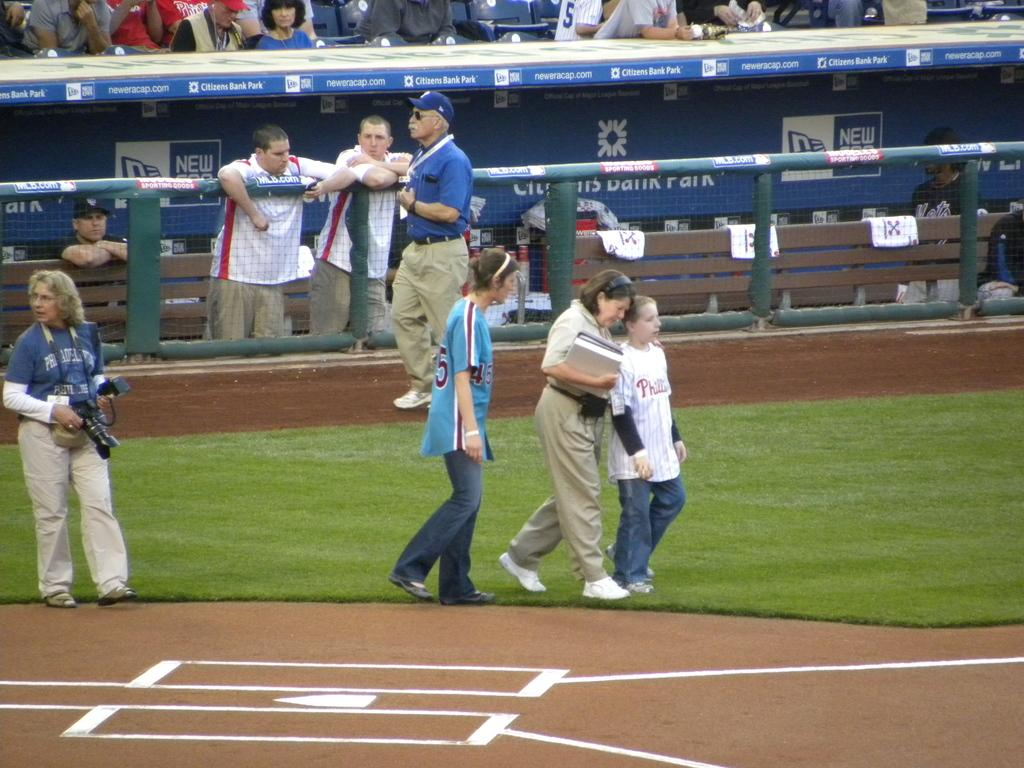<image>
Create a compact narrative representing the image presented. several people are on the baseball field that is sponsored by citizens bank 